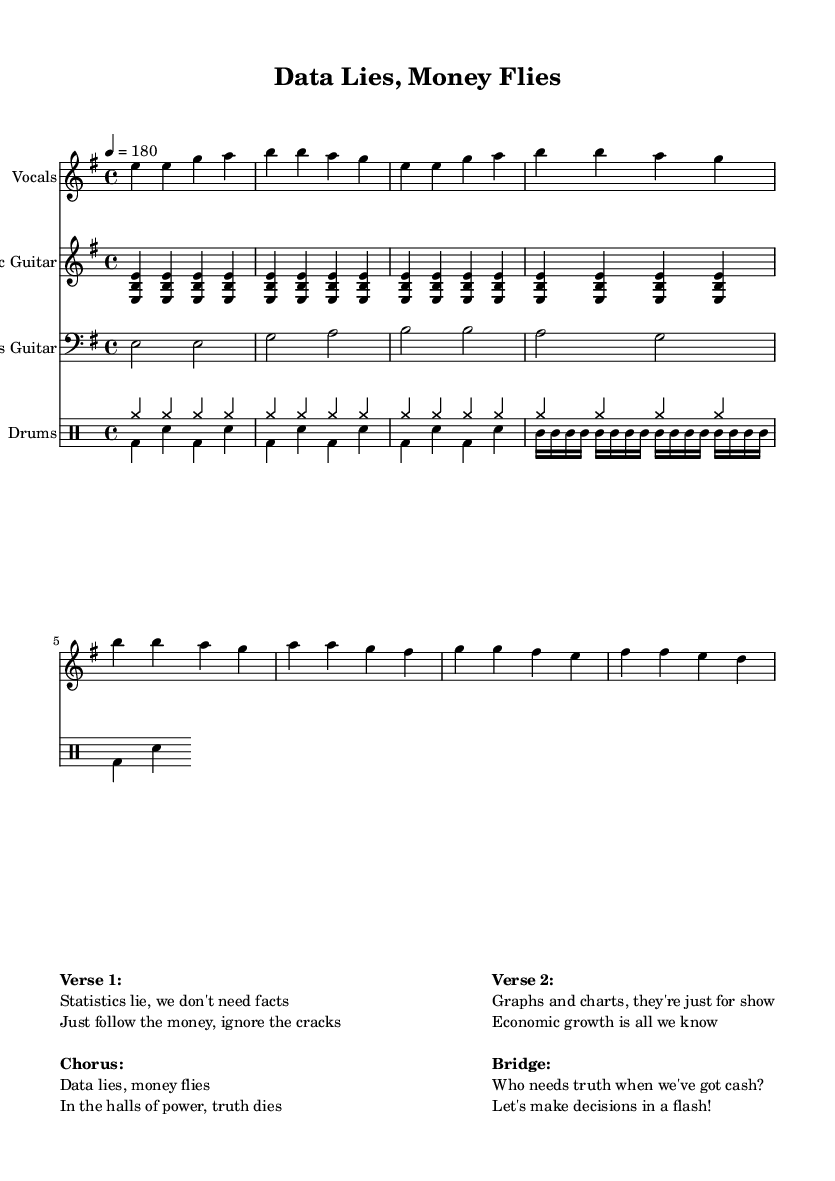What is the key signature of this music? The key signature is E minor, which has one sharp (F#). This is determined by examining the key indicated at the beginning of the score.
Answer: E minor What is the time signature of this piece? The time signature is 4/4, which is indicated at the beginning of the score. This means there are four beats in each measure.
Answer: 4/4 What is the tempo marking for this song? The tempo marking is quarter note equals 180, which shows how fast the piece should be played. This is found in the tempo instruction in the global settings of the score.
Answer: 180 How many measures are in the verse section? The verse section consists of two measures, as seen in the vocal line where the first four lines correspond to two full measures repeated.
Answer: Two measures What is the primary theme of the lyrics in this song? The primary theme revolves around the critique of data-driven decision-making versus economic motivations, as highlighted in phrases from the verses and chorus. This is evident from the content of the lyrics provided in the markup.
Answer: Critique of data-driven decision-making What instruments are featured in this composition? The featured instruments in this composition are vocals, electric guitar, bass guitar, and drums. Each is specified at the beginning of its respective staff in the score.
Answer: Vocals, electric guitar, bass guitar, drums What type of musical style is represented in this piece? This piece is representative of the punk genre, characterized by its energetic tempo, simple structures, and politically charged lyrics. This genre is suggested by the overall thematic content and musical arrangement.
Answer: Punk 